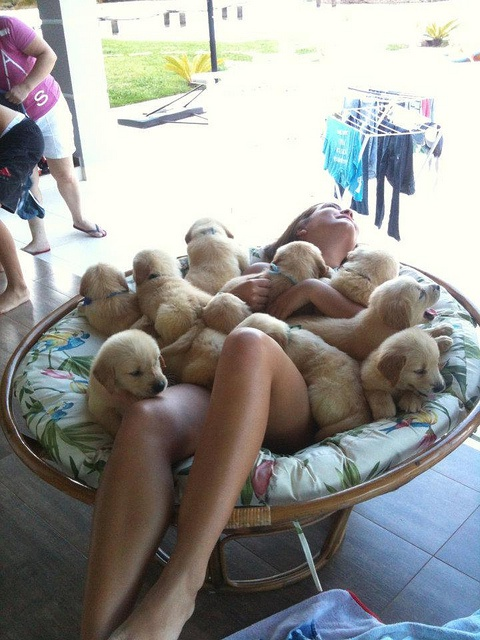Describe the objects in this image and their specific colors. I can see people in gray and maroon tones, chair in gray, black, darkgray, and lightblue tones, people in gray, white, darkgray, and purple tones, dog in gray, maroon, black, and darkgray tones, and dog in gray and black tones in this image. 